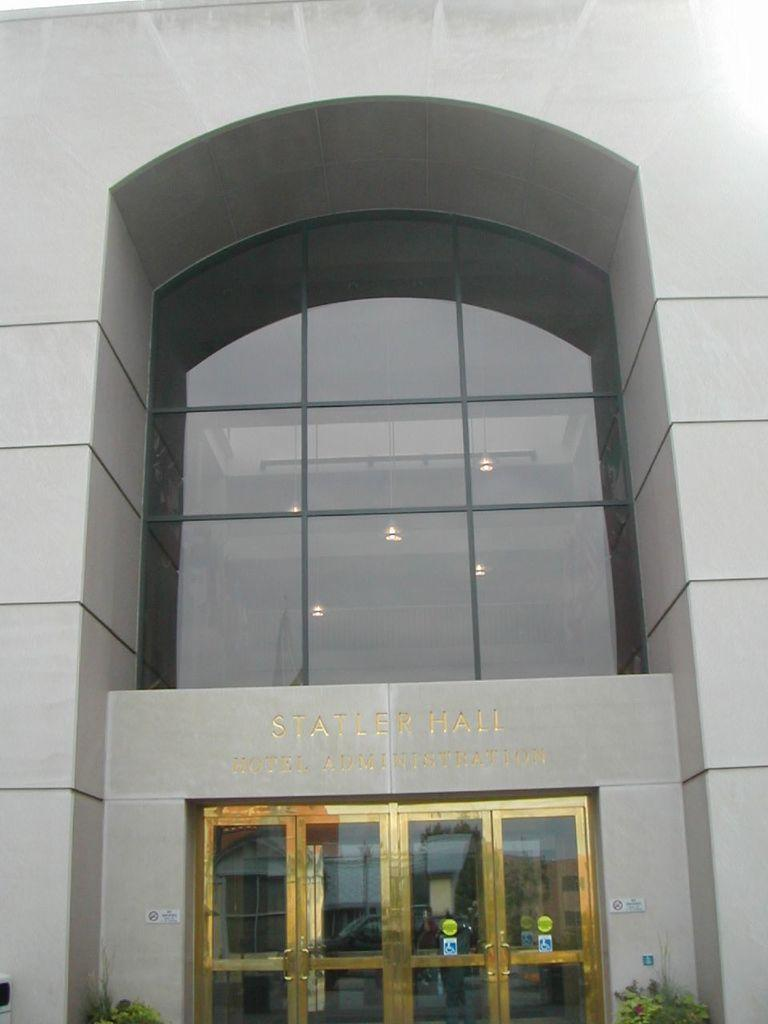What type of structure is visible in the image? There is a building in the image. What is the color of the front door of the building? The front door of the building is golden in color. What can be seen written on the top of the building? There is text written on the top of the building. What type of vegetation is present at the bottom of the image? Two plants are present at the bottom of the image. How many tickets are available for the operation in the image? There is no operation or tickets present in the image; it features a building with a golden front door, text on the top, and two plants at the bottom. 